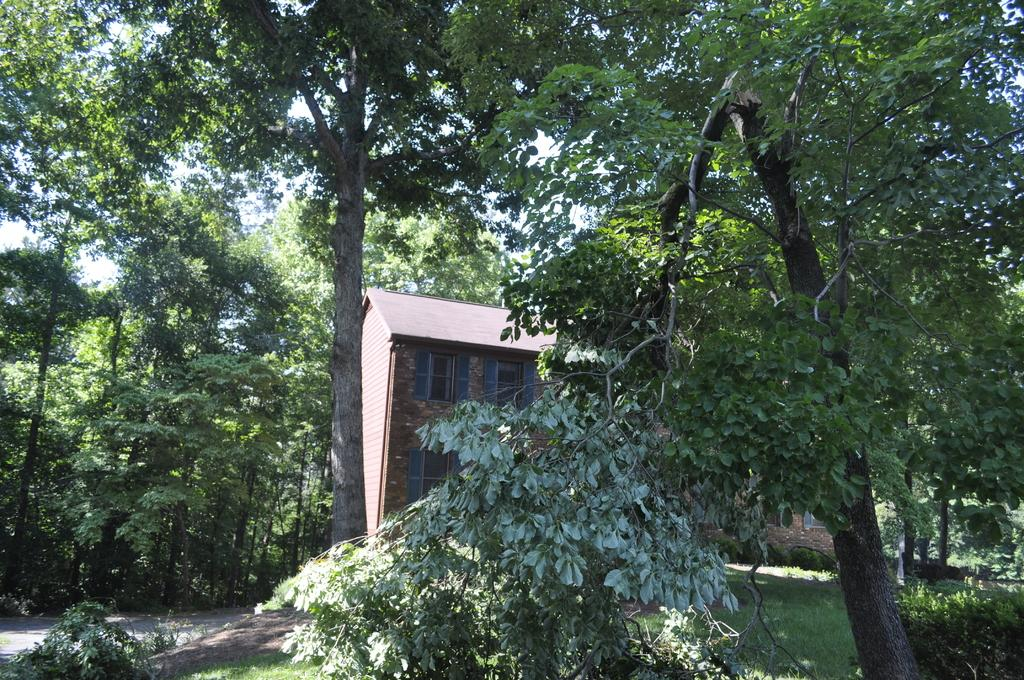What type of vegetation is present in the image? There are many trees in the image. What type of structure can be seen in the image? There is a house in the image. Where is the house located in relation to the trees? The house is located between the trees. What is the profit margin of the butter sold in the house in the image? There is no mention of butter or profit in the image, so it is not possible to answer that question. 